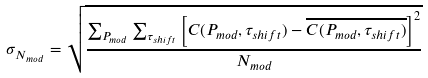Convert formula to latex. <formula><loc_0><loc_0><loc_500><loc_500>\sigma _ { N _ { m o d } } = \sqrt { \frac { \sum _ { P _ { m o d } } \sum _ { \tau _ { s h i f t } } \left [ C ( P _ { m o d } , \tau _ { s h i f t } ) - \overline { C ( P _ { m o d } , \tau _ { s h i f t } ) } \right ] ^ { 2 } } { { N _ { m o d } } } }</formula> 